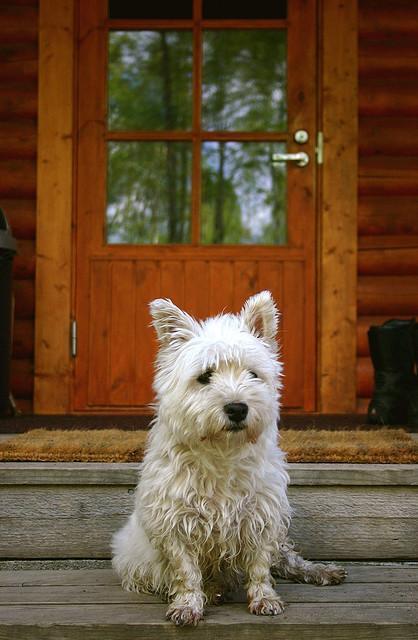How many blue cars are in the picture?
Give a very brief answer. 0. 